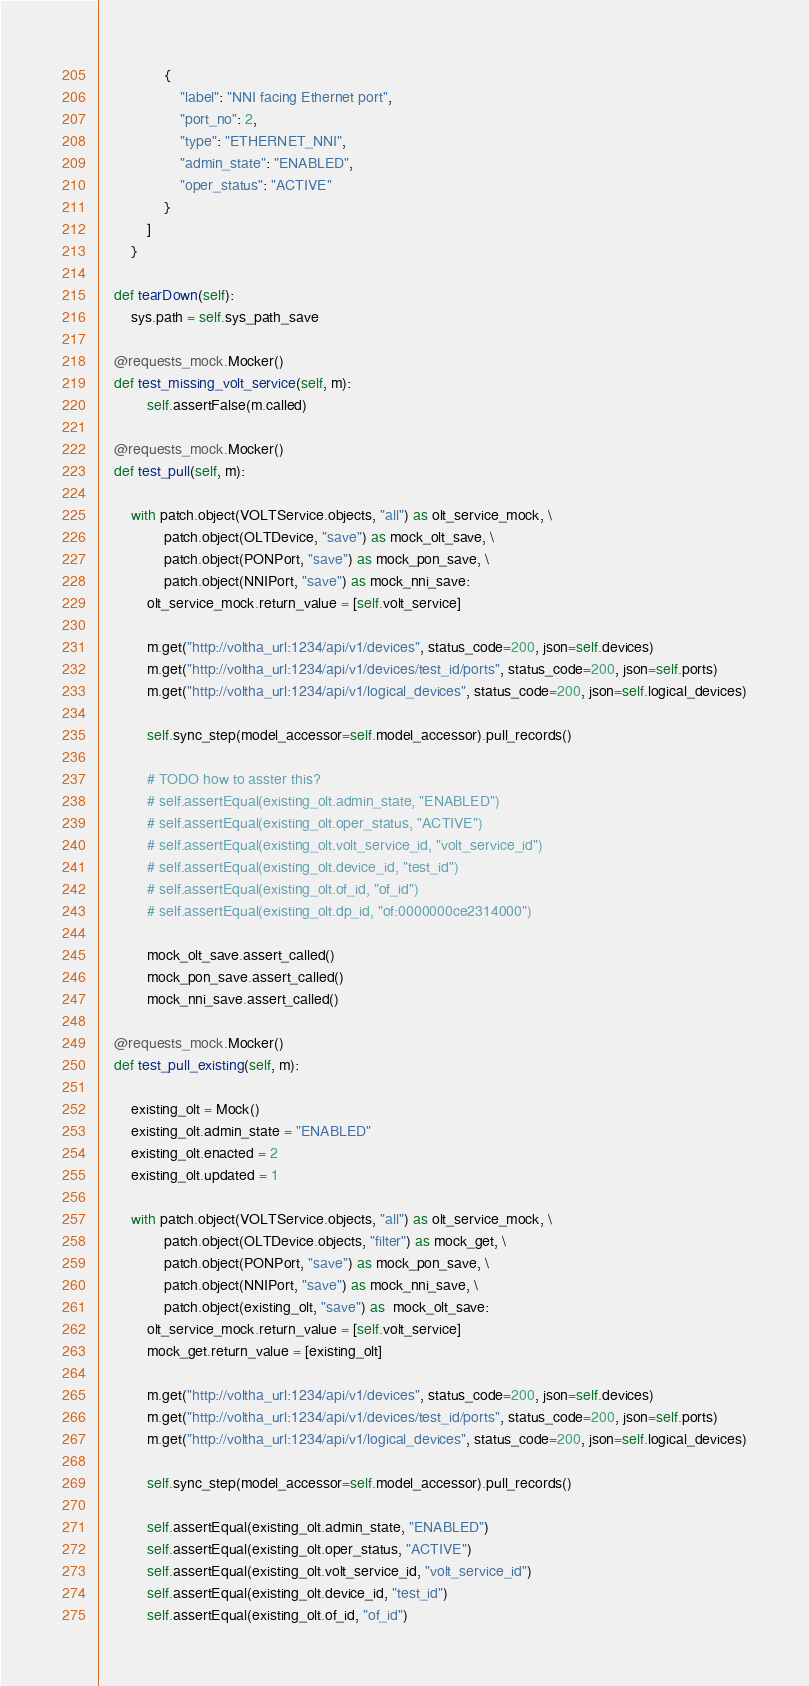<code> <loc_0><loc_0><loc_500><loc_500><_Python_>                {
                    "label": "NNI facing Ethernet port",
                    "port_no": 2,
                    "type": "ETHERNET_NNI",
                    "admin_state": "ENABLED",
                    "oper_status": "ACTIVE"
                }
            ]
        }

    def tearDown(self):
        sys.path = self.sys_path_save

    @requests_mock.Mocker()
    def test_missing_volt_service(self, m):
            self.assertFalse(m.called)

    @requests_mock.Mocker()
    def test_pull(self, m):

        with patch.object(VOLTService.objects, "all") as olt_service_mock, \
                patch.object(OLTDevice, "save") as mock_olt_save, \
                patch.object(PONPort, "save") as mock_pon_save, \
                patch.object(NNIPort, "save") as mock_nni_save:
            olt_service_mock.return_value = [self.volt_service]

            m.get("http://voltha_url:1234/api/v1/devices", status_code=200, json=self.devices)
            m.get("http://voltha_url:1234/api/v1/devices/test_id/ports", status_code=200, json=self.ports)
            m.get("http://voltha_url:1234/api/v1/logical_devices", status_code=200, json=self.logical_devices)

            self.sync_step(model_accessor=self.model_accessor).pull_records()

            # TODO how to asster this?
            # self.assertEqual(existing_olt.admin_state, "ENABLED")
            # self.assertEqual(existing_olt.oper_status, "ACTIVE")
            # self.assertEqual(existing_olt.volt_service_id, "volt_service_id")
            # self.assertEqual(existing_olt.device_id, "test_id")
            # self.assertEqual(existing_olt.of_id, "of_id")
            # self.assertEqual(existing_olt.dp_id, "of:0000000ce2314000")

            mock_olt_save.assert_called()
            mock_pon_save.assert_called()
            mock_nni_save.assert_called()

    @requests_mock.Mocker()
    def test_pull_existing(self, m):

        existing_olt = Mock()
        existing_olt.admin_state = "ENABLED"
        existing_olt.enacted = 2
        existing_olt.updated = 1

        with patch.object(VOLTService.objects, "all") as olt_service_mock, \
                patch.object(OLTDevice.objects, "filter") as mock_get, \
                patch.object(PONPort, "save") as mock_pon_save, \
                patch.object(NNIPort, "save") as mock_nni_save, \
                patch.object(existing_olt, "save") as  mock_olt_save:
            olt_service_mock.return_value = [self.volt_service]
            mock_get.return_value = [existing_olt]

            m.get("http://voltha_url:1234/api/v1/devices", status_code=200, json=self.devices)
            m.get("http://voltha_url:1234/api/v1/devices/test_id/ports", status_code=200, json=self.ports)
            m.get("http://voltha_url:1234/api/v1/logical_devices", status_code=200, json=self.logical_devices)

            self.sync_step(model_accessor=self.model_accessor).pull_records()

            self.assertEqual(existing_olt.admin_state, "ENABLED")
            self.assertEqual(existing_olt.oper_status, "ACTIVE")
            self.assertEqual(existing_olt.volt_service_id, "volt_service_id")
            self.assertEqual(existing_olt.device_id, "test_id")
            self.assertEqual(existing_olt.of_id, "of_id")</code> 